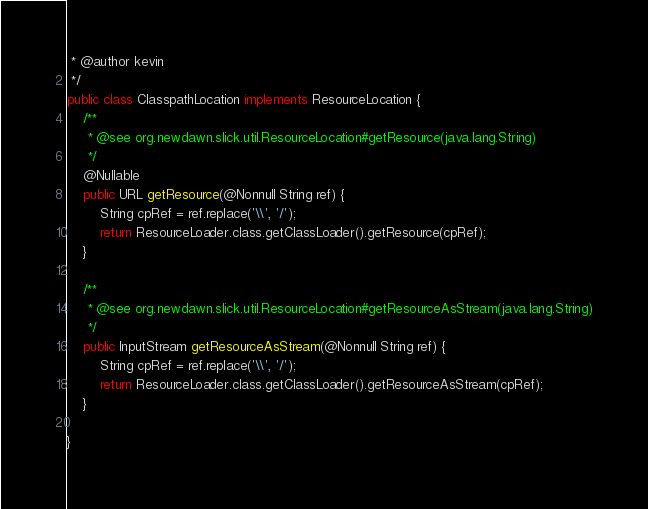Convert code to text. <code><loc_0><loc_0><loc_500><loc_500><_Java_> * @author kevin
 */
public class ClasspathLocation implements ResourceLocation {
    /**
     * @see org.newdawn.slick.util.ResourceLocation#getResource(java.lang.String)
     */
    @Nullable
    public URL getResource(@Nonnull String ref) {
        String cpRef = ref.replace('\\', '/');
        return ResourceLoader.class.getClassLoader().getResource(cpRef);
    }

    /**
     * @see org.newdawn.slick.util.ResourceLocation#getResourceAsStream(java.lang.String)
     */
    public InputStream getResourceAsStream(@Nonnull String ref) {
        String cpRef = ref.replace('\\', '/');
        return ResourceLoader.class.getClassLoader().getResourceAsStream(cpRef);
    }

}
</code> 